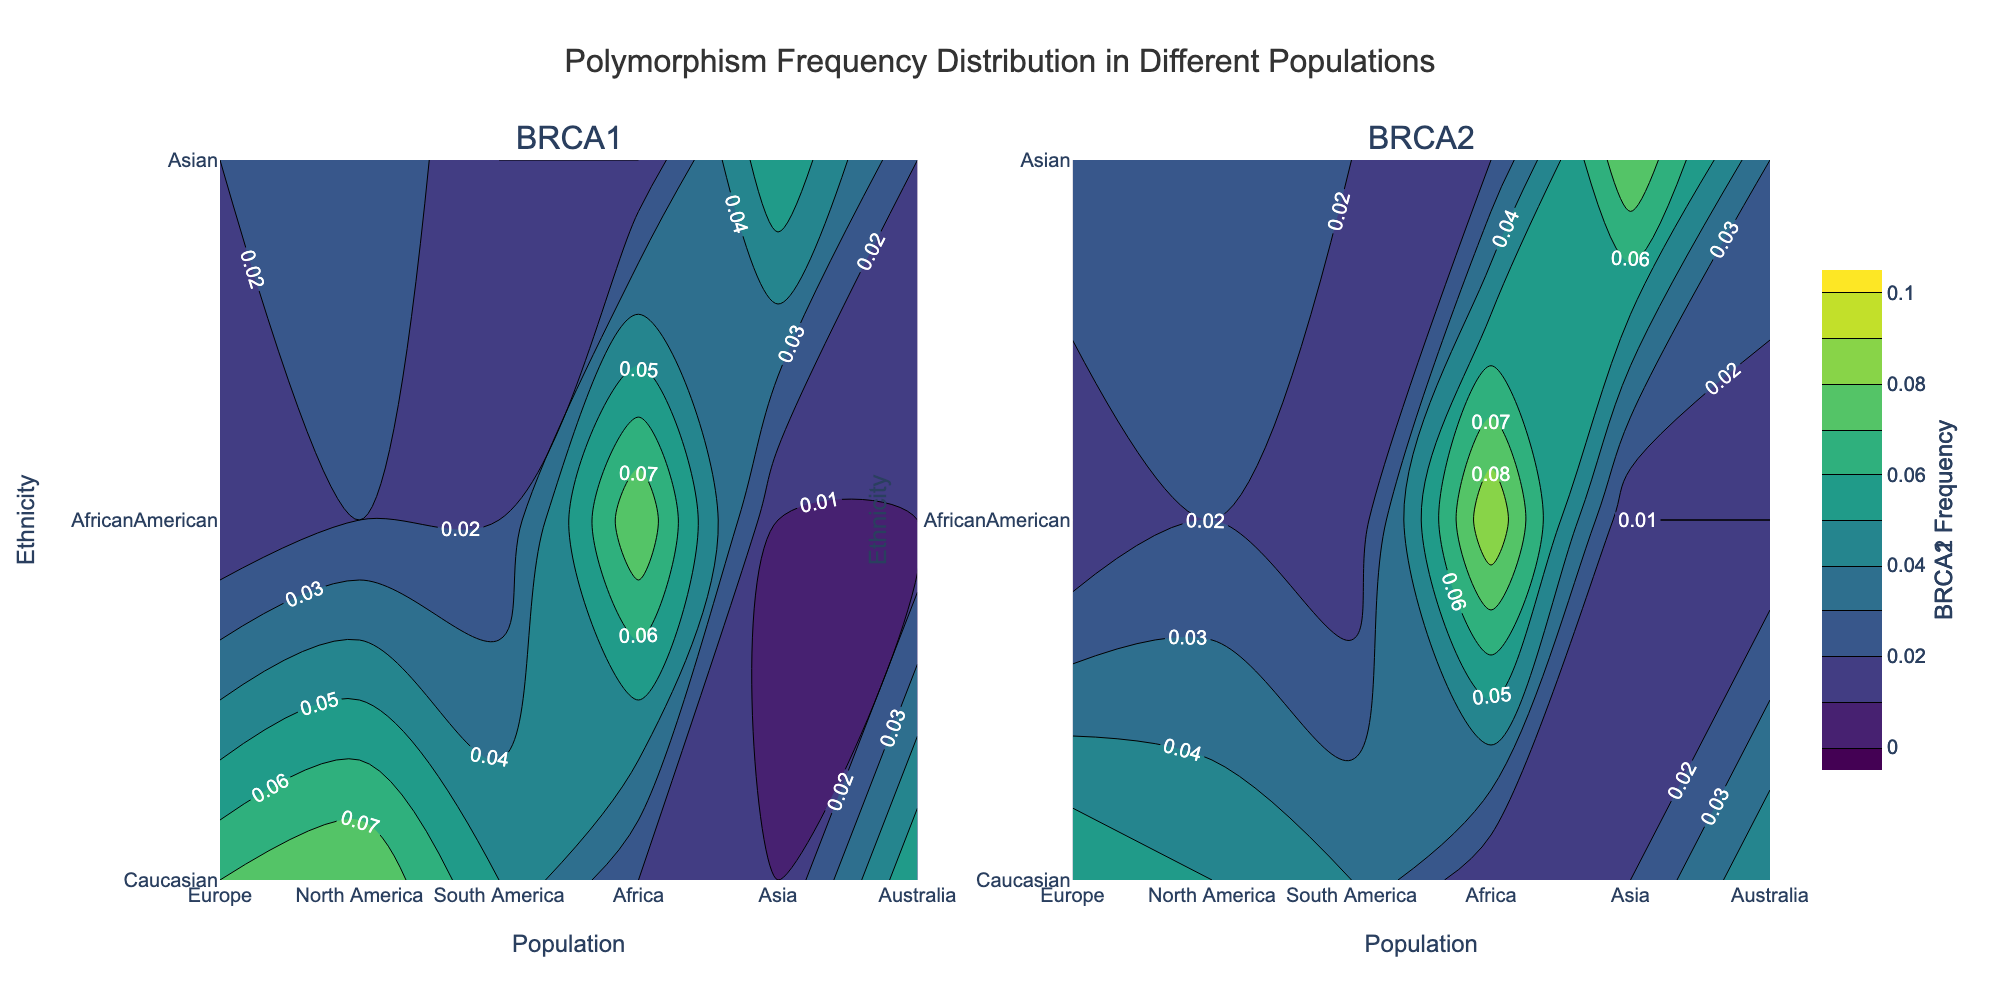What is the title of the figure? The title is found at the top center of the figure. It reads "Polymorphism Frequency Distribution in Different Populations".
Answer: Polymorphism Frequency Distribution in Different Populations Which population has the highest BRCA1 frequency for Caucasians? By looking at the contour plot for BRCA1, identify the largest value along the y-axis for 'Caucasian' across the different x-axis populations. North America has the highest frequency for Caucasians with a value of 0.08.
Answer: North America How does the BRCA2 mutation frequency for Asians in Asia compare to that for Caucasians in North America? For BRCA2, locate the value corresponding to 'Asian' in 'Asia' and 'Caucasian' in 'North America'. The values are 0.08 and 0.05, respectively, showing that the frequency for Asians in Asia is higher.
Answer: Higher Which ethnicity shows the highest variation in BRCA1 frequency across different populations? Analyze the BRCA1 contour plot. Track the values for each ethnicity across all populations. 'AfricanAmerican' shows the highest variation with frequencies ranging from 0.01 to 0.08.
Answer: AfricanAmerican What is the average BRCA1 frequency for Asians across all populations? To find the average, sum the BRCA1 frequencies for Asians across all populations and divide by the number of populations: (0.02+0.03+0.01+0.01+0.06+0.02)/6 = 0.025.
Answer: 0.025 What is the overall trend for BRCA2 frequency in Caucasians across different populations? Observe the BRCA2 contour plot for 'Caucasian' across all populations. The trend shows that frequencies remain relatively consistent, mostly around 0.05-0.06.
Answer: Consistent Which two populations show the greatest difference in BRCA1 frequency for 'Asian'? Examine the BRCA1 contour plot and identify the highest and lowest frequencies for 'Asian' across all populations. Asia (0.06) and South America or Africa (0.01) represent the extremes, with a difference of 0.05.
Answer: Asia and South America/Africa In which population is the BRCA1 frequency for 'AfricanAmerican' twice that of 'Asian'? For BRCA1, compare frequencies for 'AfricanAmerican' and 'Asian' within each population. In Africa, 'AfricanAmerican' has a frequency of 0.08, which is approximately twice that of 'Asian' (0.01).
Answer: Africa Which gene shows a broader color range in the contour plot and what does it indicate? Compare the color gradients in both BRCA1 and BRCA2 plots. BRCA1 shows a broader range of colors indicating greater variability in the frequency data across populations and ethnicities.
Answer: BRCA1 What is the sum of BRCA2 frequencies for 'AfricanAmerican' in North America and Africa? Look at the BRCA2 values for 'AfricanAmerican' in 'North America' (0.02) and 'Africa' (0.09), add them together: 0.02 + 0.09 = 0.11.
Answer: 0.11 